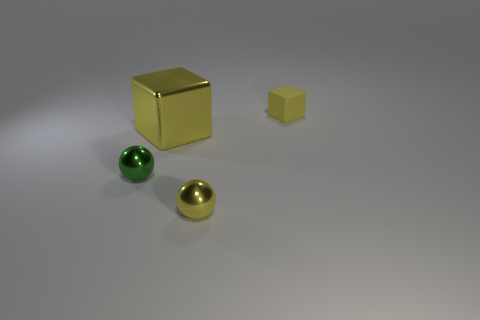Subtract 1 balls. How many balls are left? 1 Subtract all green cylinders. How many green spheres are left? 1 Add 2 brown metal cylinders. How many objects exist? 6 Subtract all yellow metal balls. Subtract all brown rubber cylinders. How many objects are left? 3 Add 3 green metal spheres. How many green metal spheres are left? 4 Add 3 big yellow cylinders. How many big yellow cylinders exist? 3 Subtract 1 yellow cubes. How many objects are left? 3 Subtract all green blocks. Subtract all gray spheres. How many blocks are left? 2 